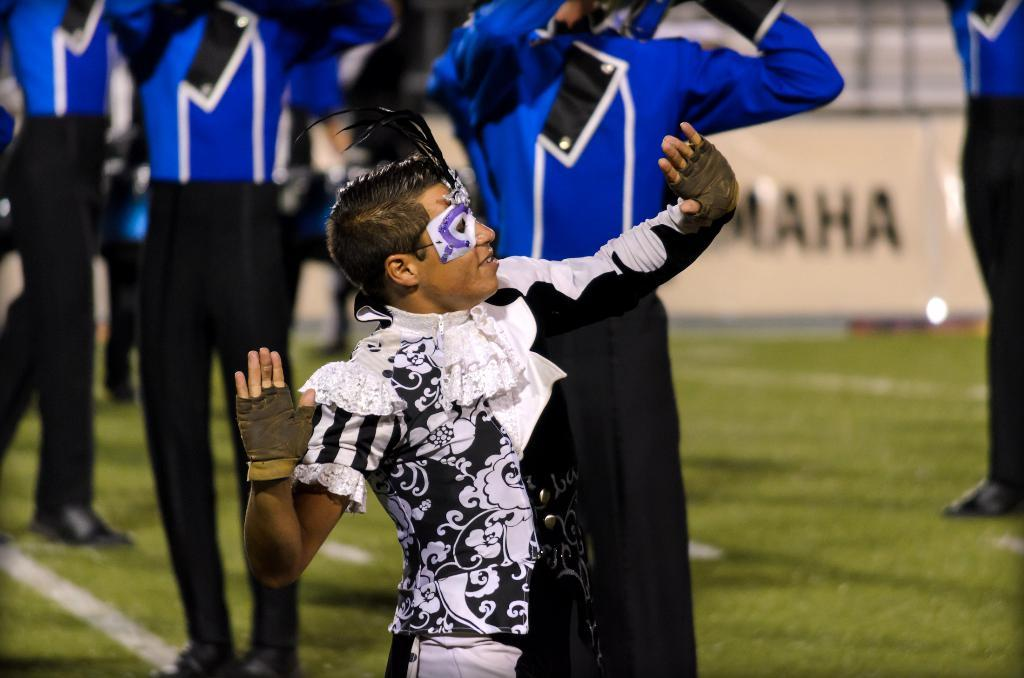<image>
Give a short and clear explanation of the subsequent image. a man dressed in a mask and black and white costume with the letters MAHA written on the white sign behind him 